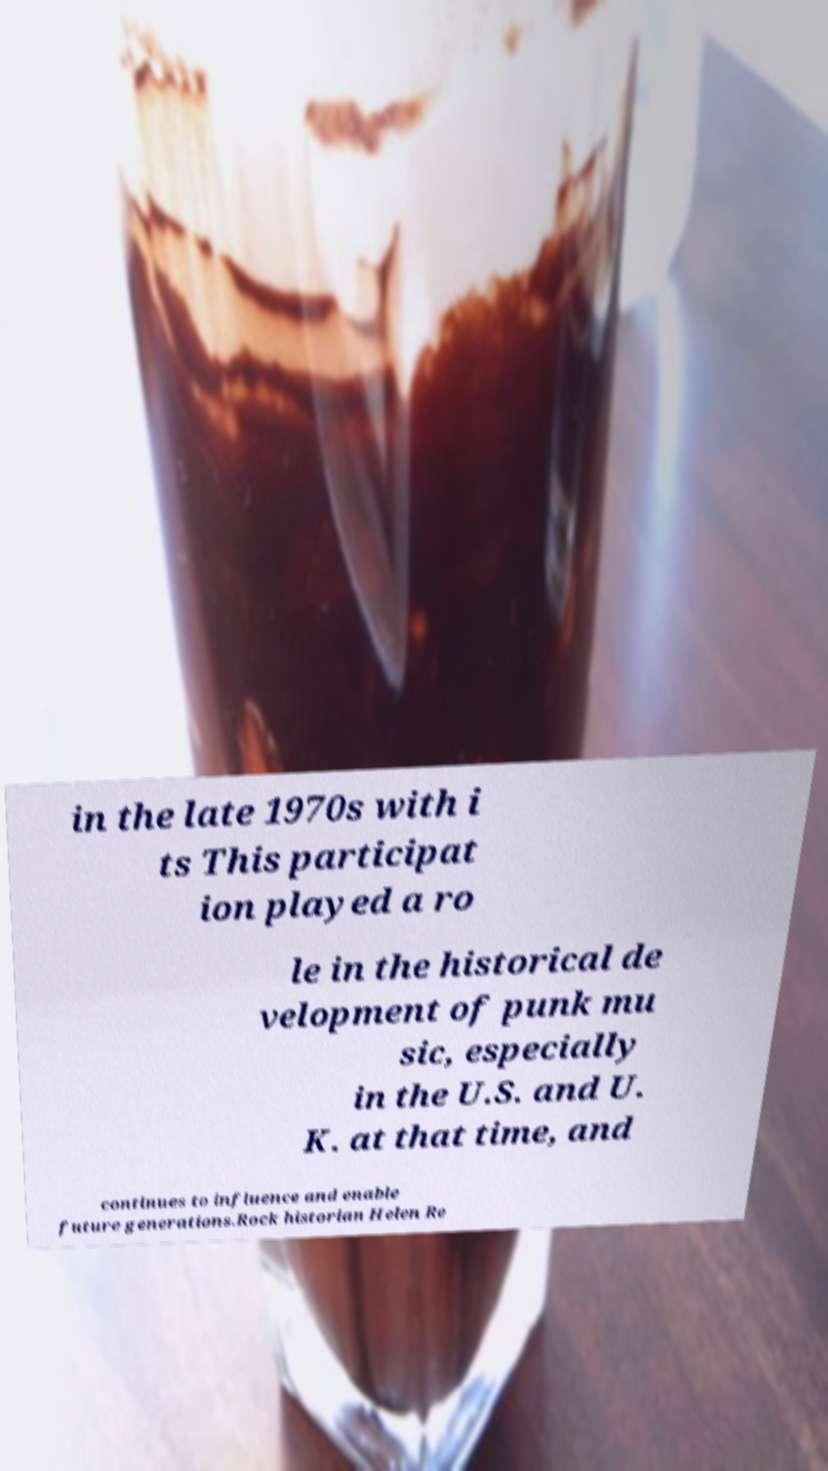Please identify and transcribe the text found in this image. in the late 1970s with i ts This participat ion played a ro le in the historical de velopment of punk mu sic, especially in the U.S. and U. K. at that time, and continues to influence and enable future generations.Rock historian Helen Re 